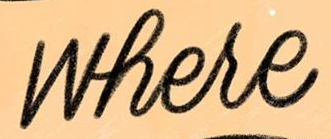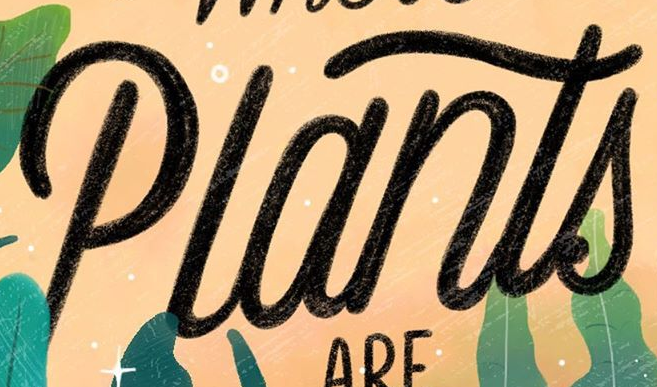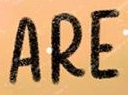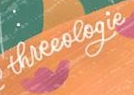Read the text from these images in sequence, separated by a semicolon. where; Plants; ARE; threeologie 